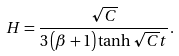Convert formula to latex. <formula><loc_0><loc_0><loc_500><loc_500>H = \frac { \sqrt { C } } { 3 \left ( \beta + 1 \right ) \tanh { \sqrt { C } t } } .</formula> 